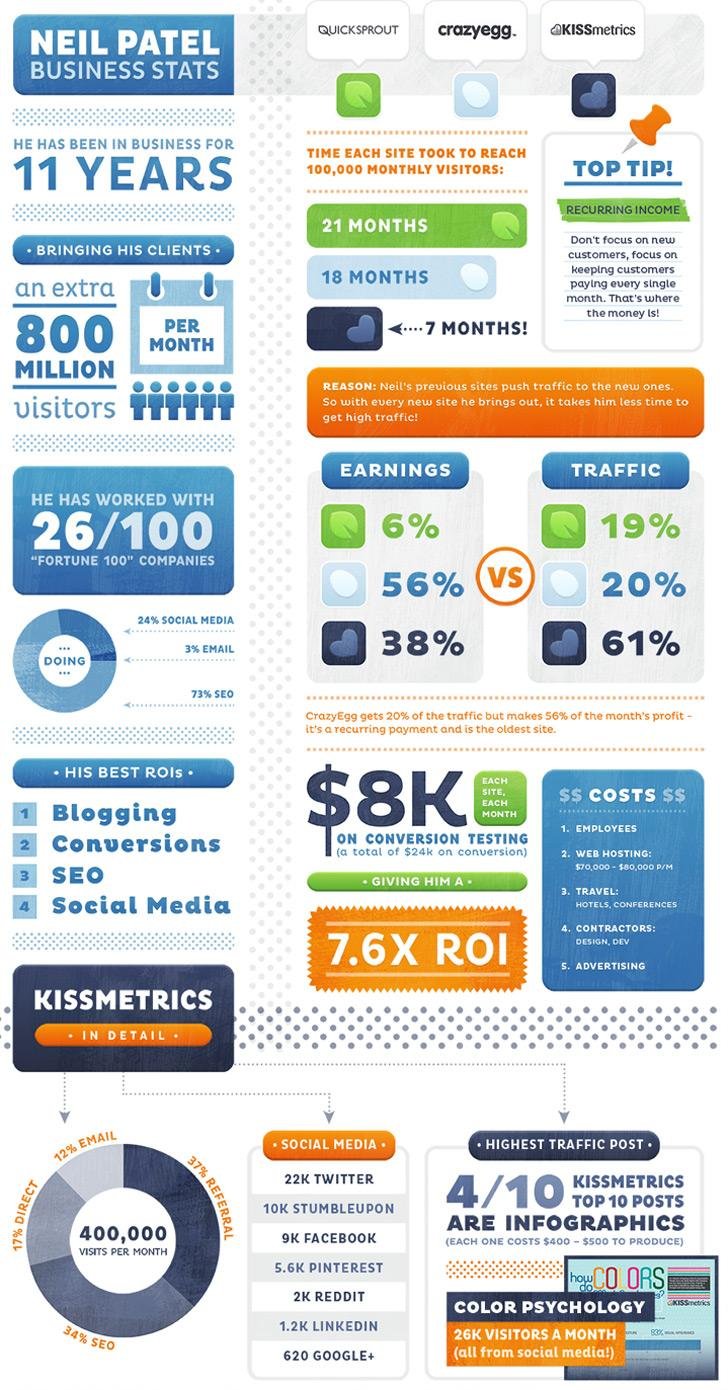List a handful of essential elements in this visual. QuickSprout took 21 months to reach 100,000 monthly visitors. Crazyegg reached 100,000 monthly visitors in 18 months. According to Kissmetrics, 34% of people use search engine optimization. The individual derives a significant portion of his return on investment from social media, earning it a top spot as one of his best sources of return on investment. He derives his third best return on investment from SEO. 